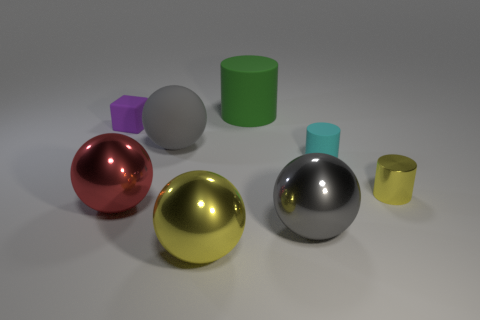Subtract all gray spheres. How many were subtracted if there are1gray spheres left? 1 Subtract 1 balls. How many balls are left? 3 Add 1 big blue shiny cylinders. How many objects exist? 9 Subtract all cylinders. How many objects are left? 5 Subtract all small yellow metallic cylinders. Subtract all gray metallic spheres. How many objects are left? 6 Add 4 green cylinders. How many green cylinders are left? 5 Add 8 large yellow metallic objects. How many large yellow metallic objects exist? 9 Subtract 0 red cubes. How many objects are left? 8 